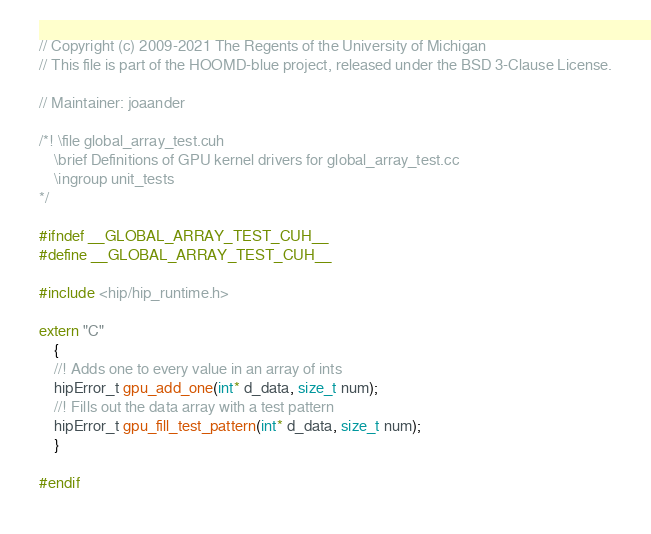<code> <loc_0><loc_0><loc_500><loc_500><_Cuda_>// Copyright (c) 2009-2021 The Regents of the University of Michigan
// This file is part of the HOOMD-blue project, released under the BSD 3-Clause License.

// Maintainer: joaander

/*! \file global_array_test.cuh
    \brief Definitions of GPU kernel drivers for global_array_test.cc
    \ingroup unit_tests
*/

#ifndef __GLOBAL_ARRAY_TEST_CUH__
#define __GLOBAL_ARRAY_TEST_CUH__

#include <hip/hip_runtime.h>

extern "C"
    {
    //! Adds one to every value in an array of ints
    hipError_t gpu_add_one(int* d_data, size_t num);
    //! Fills out the data array with a test pattern
    hipError_t gpu_fill_test_pattern(int* d_data, size_t num);
    }

#endif
</code> 